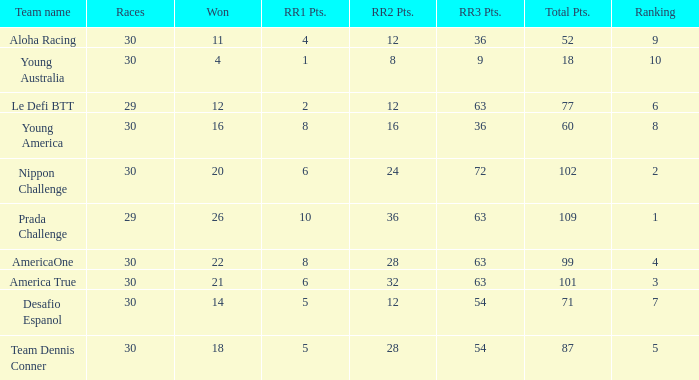Name the min total pts for team dennis conner 87.0. 